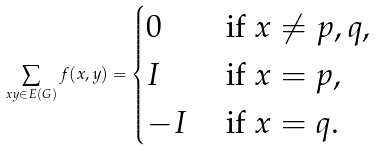Convert formula to latex. <formula><loc_0><loc_0><loc_500><loc_500>\sum _ { x y \in E ( G ) } f ( x , y ) = \begin{cases} 0 & \text { if $x \neq p,q$,} \\ I & \text { if $x= p$,} \\ - I & \text { if $x=q$} . \end{cases}</formula> 